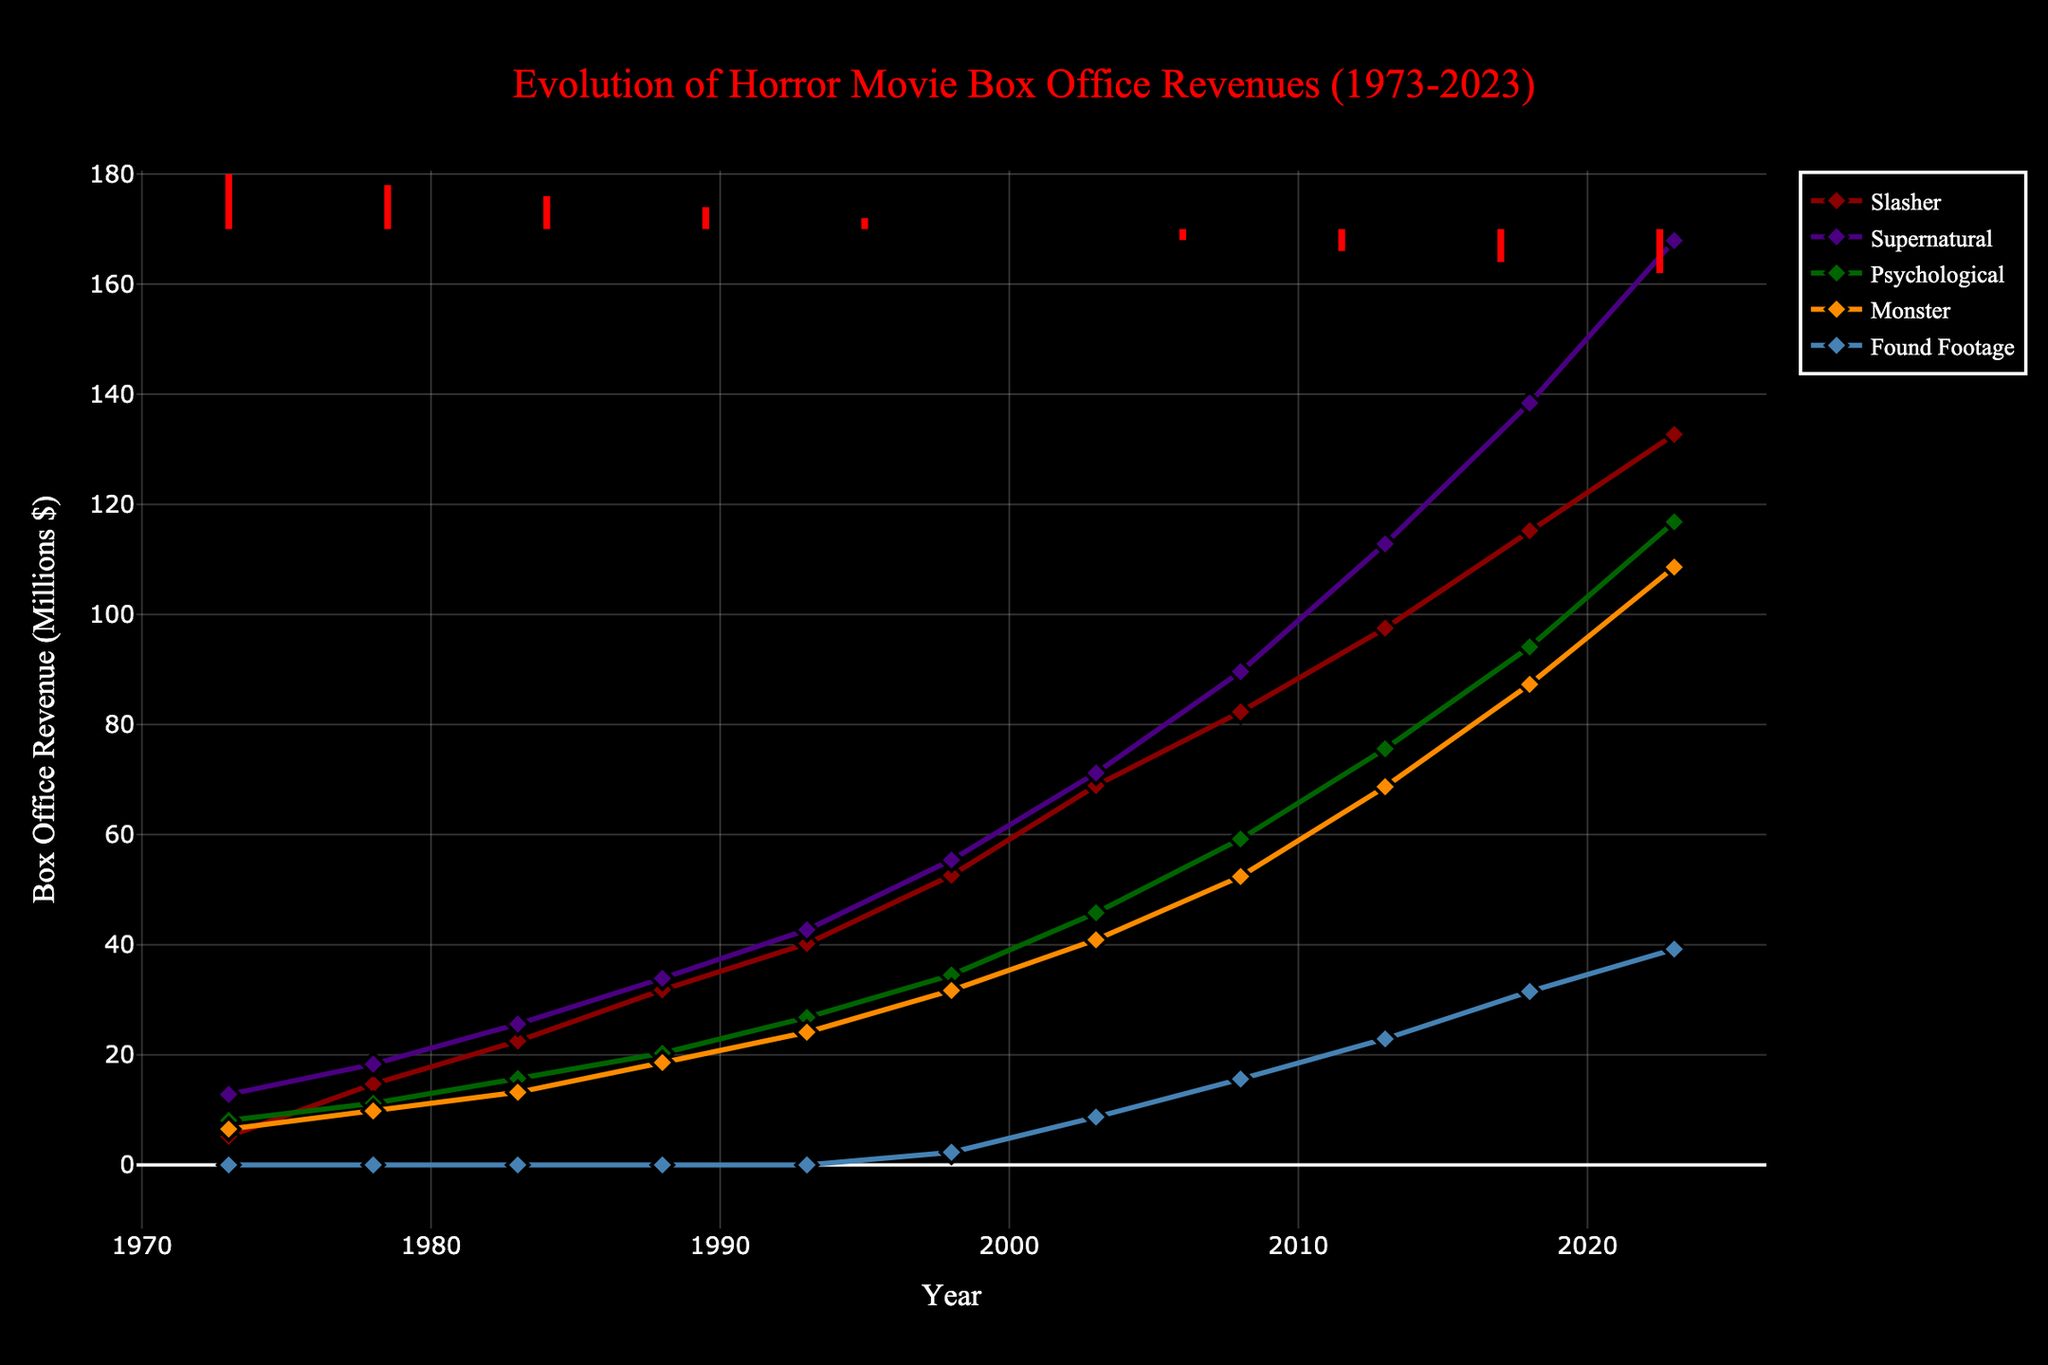What is the overall trend in the box office revenues for the 'Slasher' subgenre from 1973 to 2023? First, look at the points representing 'Slasher' revenues in each year from 1973 to 2023. Notice that the points are consistently increasing, indicating a steady rise in revenue over the 50 years.
Answer: Increasing Between which years do we see the biggest jump in box office revenue for the 'Supernatural' subgenre? Compare each consecutive pair of points for 'Supernatural' on the chart. The largest vertical gap clearly appears between 2013 and 2018, showing the biggest jump in that period.
Answer: 2013 and 2018 In 2023, which subgenre has the highest box office revenue and which has the lowest? Look at the endpoints of each line for the year 2023 and compare their vertical positions. 'Supernatural' is the highest, and 'Found Footage' is the lowest.
Answer: Highest: Supernatural, Lowest: Found Footage How much did the 'Psychological' subgenre box office revenue increase from 1973 to 2023? Find the points corresponding to 'Psychological' in 1973 (8.1) and 2023 (116.8). Subtract the revenue in 1973 from the revenue in 2023: 116.8 - 8.1 = 108.7.
Answer: 108.7 What is the average box office revenue for the 'Found Footage' subgenre over the years it was present (from 1998 to 2023)? Add up the 'Found Footage' revenues from 1998 to 2023: 2.3 + 8.7 + 15.6 + 22.9 + 31.5 + 39.2 = 120.2. Then divide by the number of years it was present: 120.2 / 6 = 20.03.
Answer: 20.03 Which subgenre had the steadiest growth over the 50-year period, and how can you tell visually? Compare the slope and consistency of each line from 1973 to 2023. The 'Monster' line shows the most consistent, linear growth without sharp jumps or drops.
Answer: Monster How does the box office revenue growth of 'Slasher' compare to 'Supernatural' from 1973 to 2023? Examine both lines over the years. Both show increasing trends, but 'Supernatural' not only starts higher but also grows at a faster rate than 'Slasher', with a steeper slope particularly noticeable after 2008.
Answer: Supernatural is faster Between 2008 and 2023, which subgenre experienced the most significant increase in box office revenue? Calculate the differences for each subgenre between 2008 and 2023. For 'Slasher', it's 132.7 - 82.3 = 50.4; for 'Supernatural', it's 167.9 - 89.6 = 78.3, and so forth. The largest difference is for 'Supernatural', 78.3.
Answer: Supernatural During which decade did the 'Psychological' subgenre experience the sharpest increase in box office revenue? Compare the increases in 'Psychological' revenue across each decade: 8.1 to 11.2 (1973-1983), 15.7 to 26.8 (1983-1993), etc. The sharpest increase is between 2003 and 2013: 45.8 to 75.6.
Answer: 2003 to 2013 